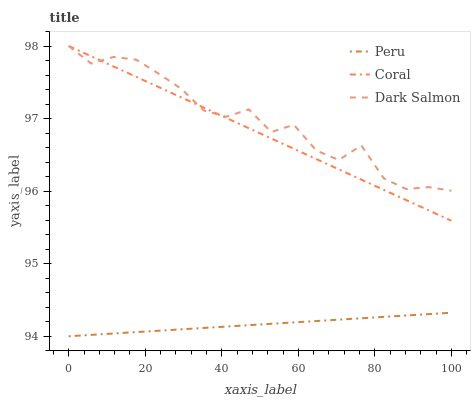Does Peru have the minimum area under the curve?
Answer yes or no. Yes. Does Dark Salmon have the maximum area under the curve?
Answer yes or no. Yes. Does Dark Salmon have the minimum area under the curve?
Answer yes or no. No. Does Peru have the maximum area under the curve?
Answer yes or no. No. Is Coral the smoothest?
Answer yes or no. Yes. Is Dark Salmon the roughest?
Answer yes or no. Yes. Is Peru the smoothest?
Answer yes or no. No. Is Peru the roughest?
Answer yes or no. No. Does Peru have the lowest value?
Answer yes or no. Yes. Does Dark Salmon have the lowest value?
Answer yes or no. No. Does Dark Salmon have the highest value?
Answer yes or no. Yes. Does Peru have the highest value?
Answer yes or no. No. Is Peru less than Dark Salmon?
Answer yes or no. Yes. Is Coral greater than Peru?
Answer yes or no. Yes. Does Coral intersect Dark Salmon?
Answer yes or no. Yes. Is Coral less than Dark Salmon?
Answer yes or no. No. Is Coral greater than Dark Salmon?
Answer yes or no. No. Does Peru intersect Dark Salmon?
Answer yes or no. No. 